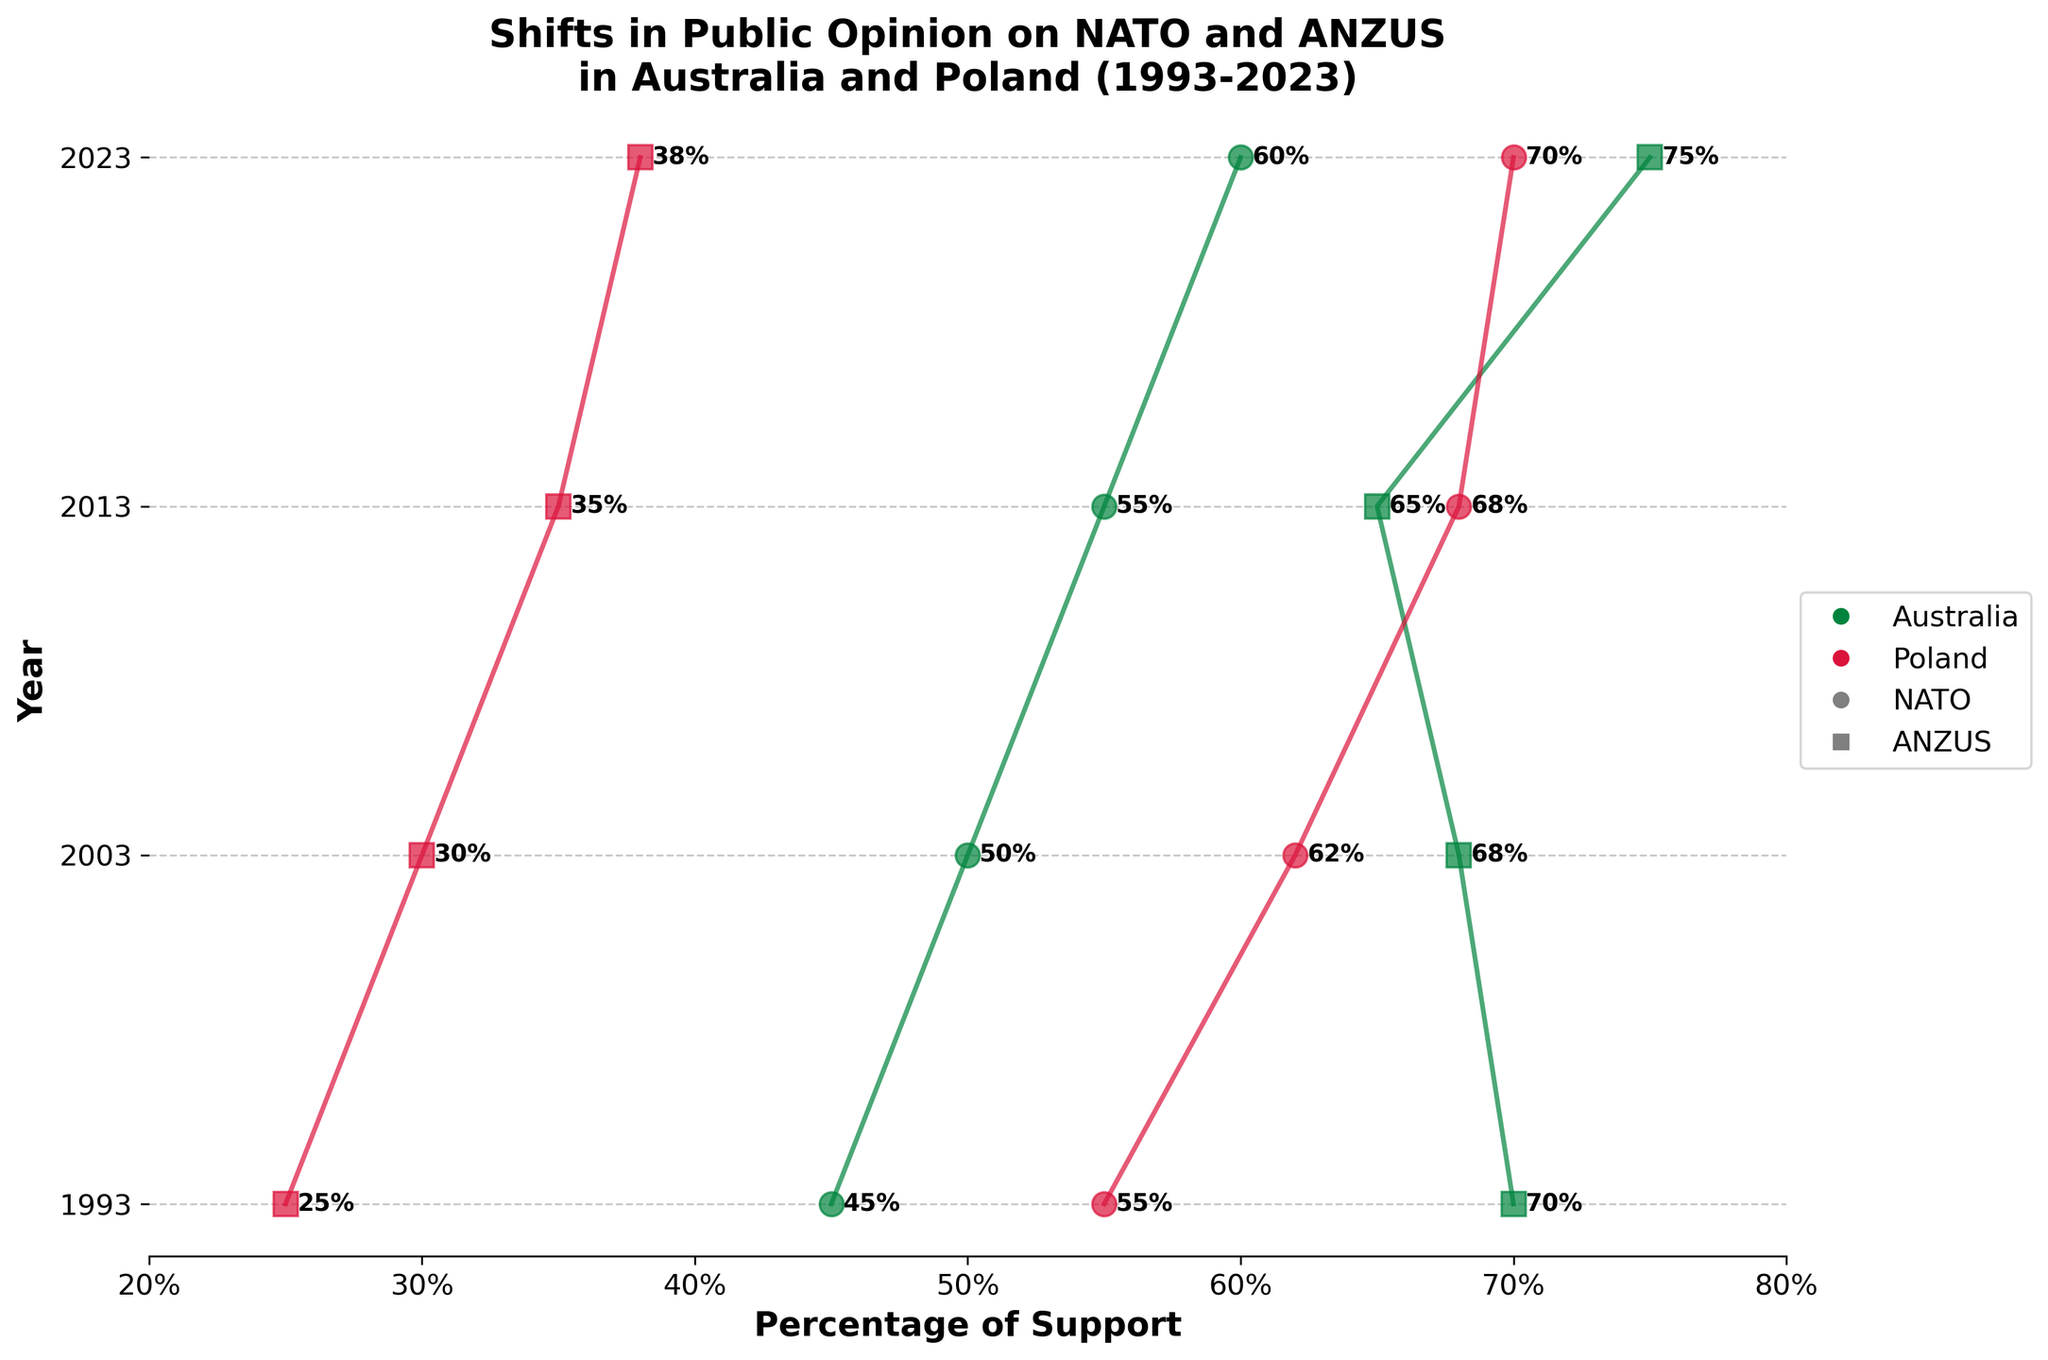Which country showed a higher support percentage for NATO in 1993? In 1993, we check the bars corresponding to Australia and Poland for NATO. We see that Poland had a higher percentage of support for NATO (55%) compared to Australia (45%).
Answer: Poland In which year did Australia have the lowest support for ANZUS? Review the plotted data points for Australia over different years. The lowest value for ANZUS support is in 2013, where the support percentage is 65%.
Answer: 2013 What is the difference in support for NATO between Australia and Poland in 2023? In 2023, Australia had 60% support for NATO and Poland had 70% support. The difference is 70% - 60% = 10%.
Answer: 10% Between 1993 and 2023, in which year did Poland see the greatest increase in support for NATO? We compare the NATO support percentages for Poland over the years. The greatest increase occurred between 1993 (55%) and 2023 (70%), which is a difference of 15%.
Answer: 2023 How did the support for ANZUS change in Australia from 2003 to 2023? Looking at the plot for ANZUS in Australia over the years, the percentage of support changed from 68% in 2003 to 75% in 2023. The change is 75% - 68% = 7% increase.
Answer: 7% increase What was the trend in support for NATO in Poland from 1993 to 2023? By examining the data points for Poland's NATO support, we see an increasing trend: 55% in 1993, 62% in 2003, 68% in 2013, and 70% in 2023.
Answer: Increasing Was there any year when Australia's support for NATO surpassed 50%? Reviewing the data points for Australia regarding NATO over the years, the support percentages surpassed 50% in 2003 (50%), 2013 (55%), and 2023 (60%).
Answer: Yes Between Australia and Poland, which country had greater variability in support percentage for ANZUS? By comparing the changes in support for ANZUS over the years, Poland's support moved from 25% in 1993 to 38% in 2023, showing less variability. Australia went from 70% in 1993 to 75% in 2023, showing slight changes. Australia had greater variability.
Answer: Australia 